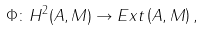Convert formula to latex. <formula><loc_0><loc_0><loc_500><loc_500>\Phi \colon H ^ { 2 } ( A , M ) \rightarrow E x t \left ( A , M \right ) ,</formula> 